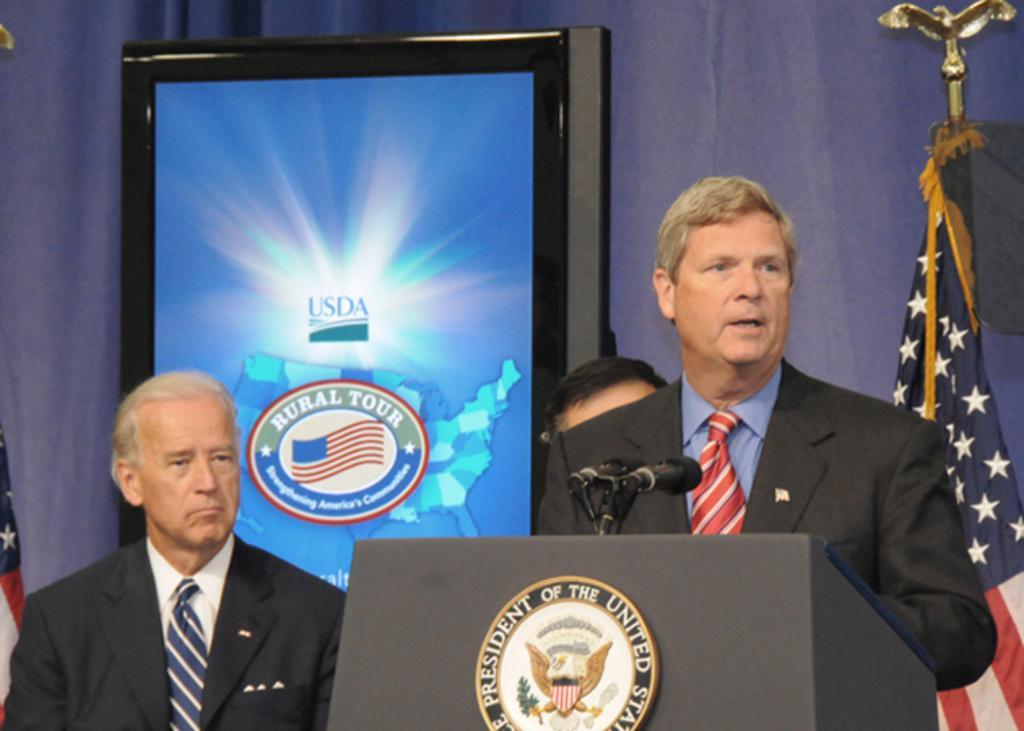Describe this image in one or two sentences. In this picture we can observe three members standing. One of the men was standing in front of a podium on which there are two mics. We can observe a white color badge on the podium. The man is wearing a black color coat and a red color tie. On the right side there is a flag. We can observe a screen in the background. There is a purple color curtain behind the screen. 